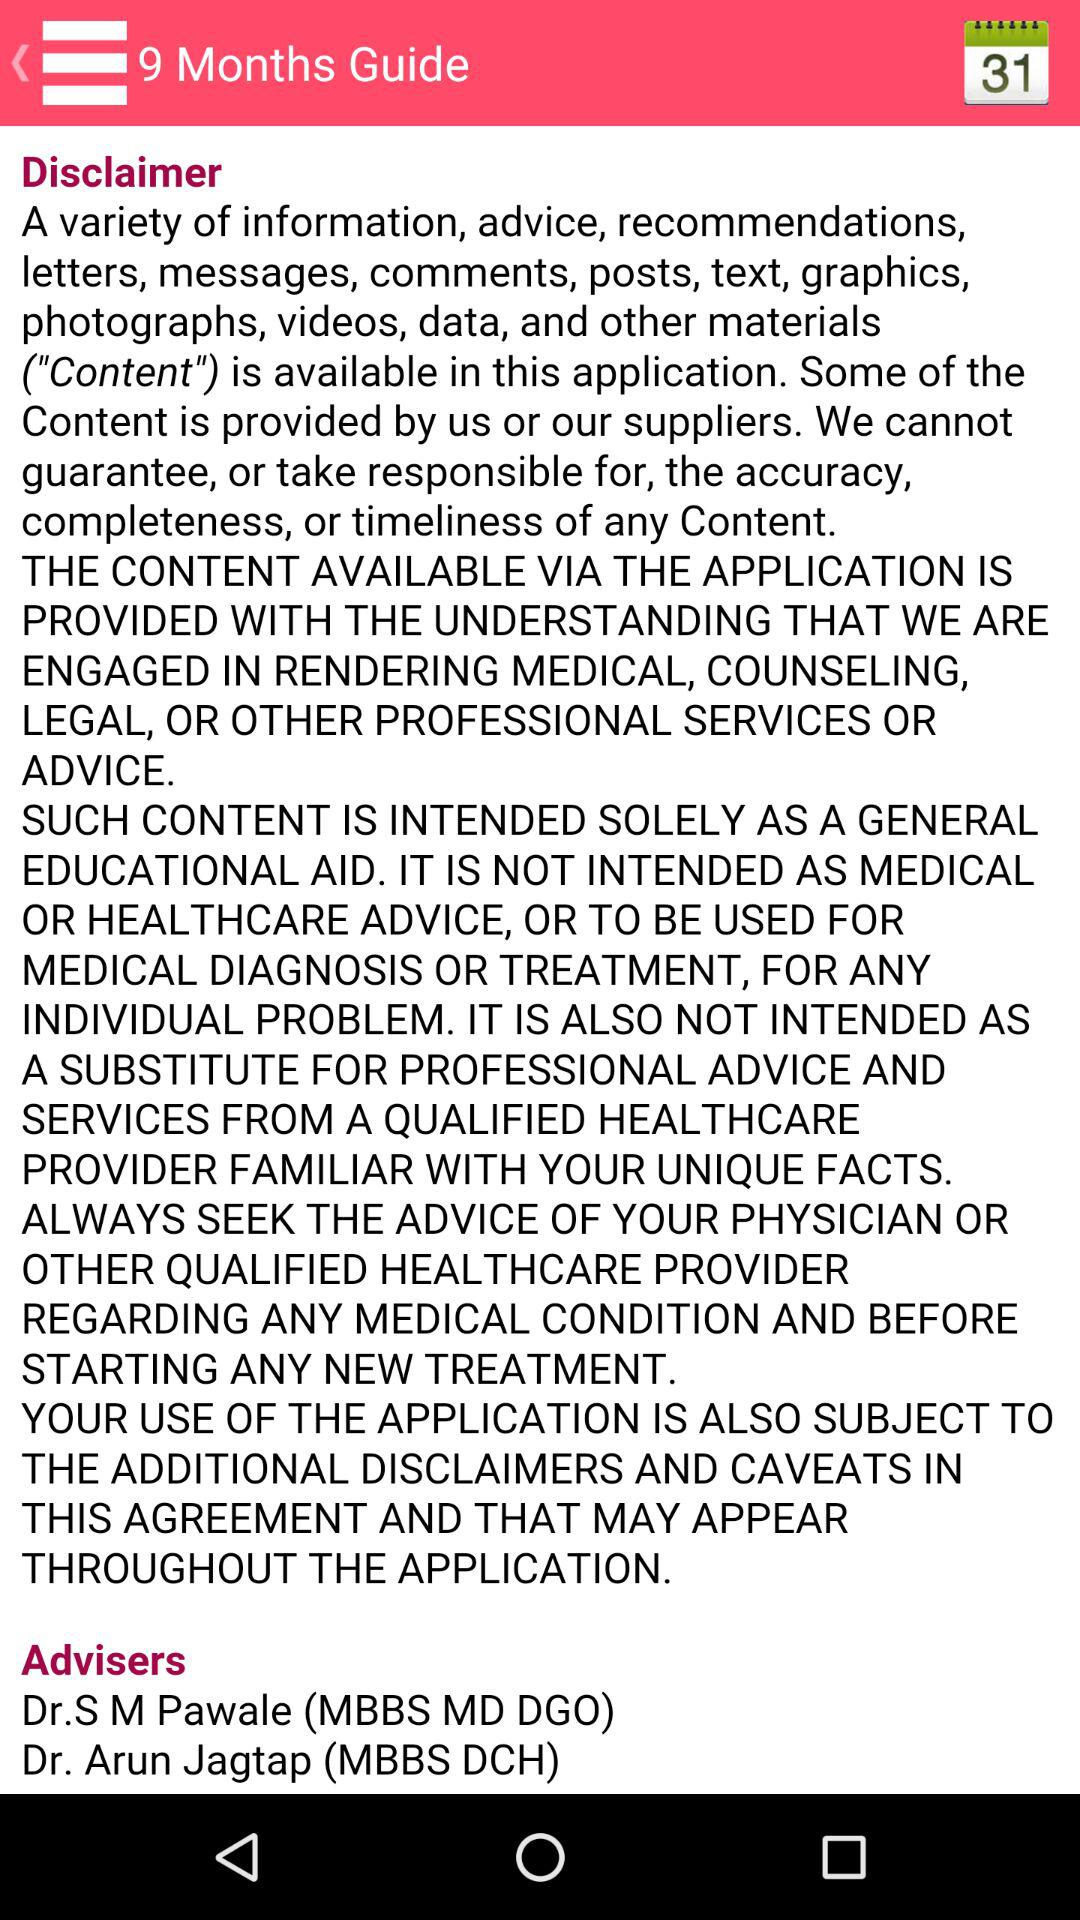When was the copyright established?
When the provided information is insufficient, respond with <no answer>. <no answer> 